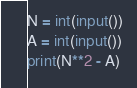<code> <loc_0><loc_0><loc_500><loc_500><_Python_>N = int(input())
A = int(input())
print(N**2 - A)
</code> 